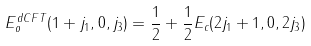Convert formula to latex. <formula><loc_0><loc_0><loc_500><loc_500>E _ { o } ^ { d C F T } ( 1 + j _ { 1 } , 0 , j _ { 3 } ) = \frac { 1 } { 2 } + \frac { 1 } { 2 } E _ { c } ( 2 j _ { 1 } + 1 , 0 , 2 j _ { 3 } )</formula> 